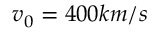<formula> <loc_0><loc_0><loc_500><loc_500>v _ { 0 } = 4 0 0 k m / s</formula> 